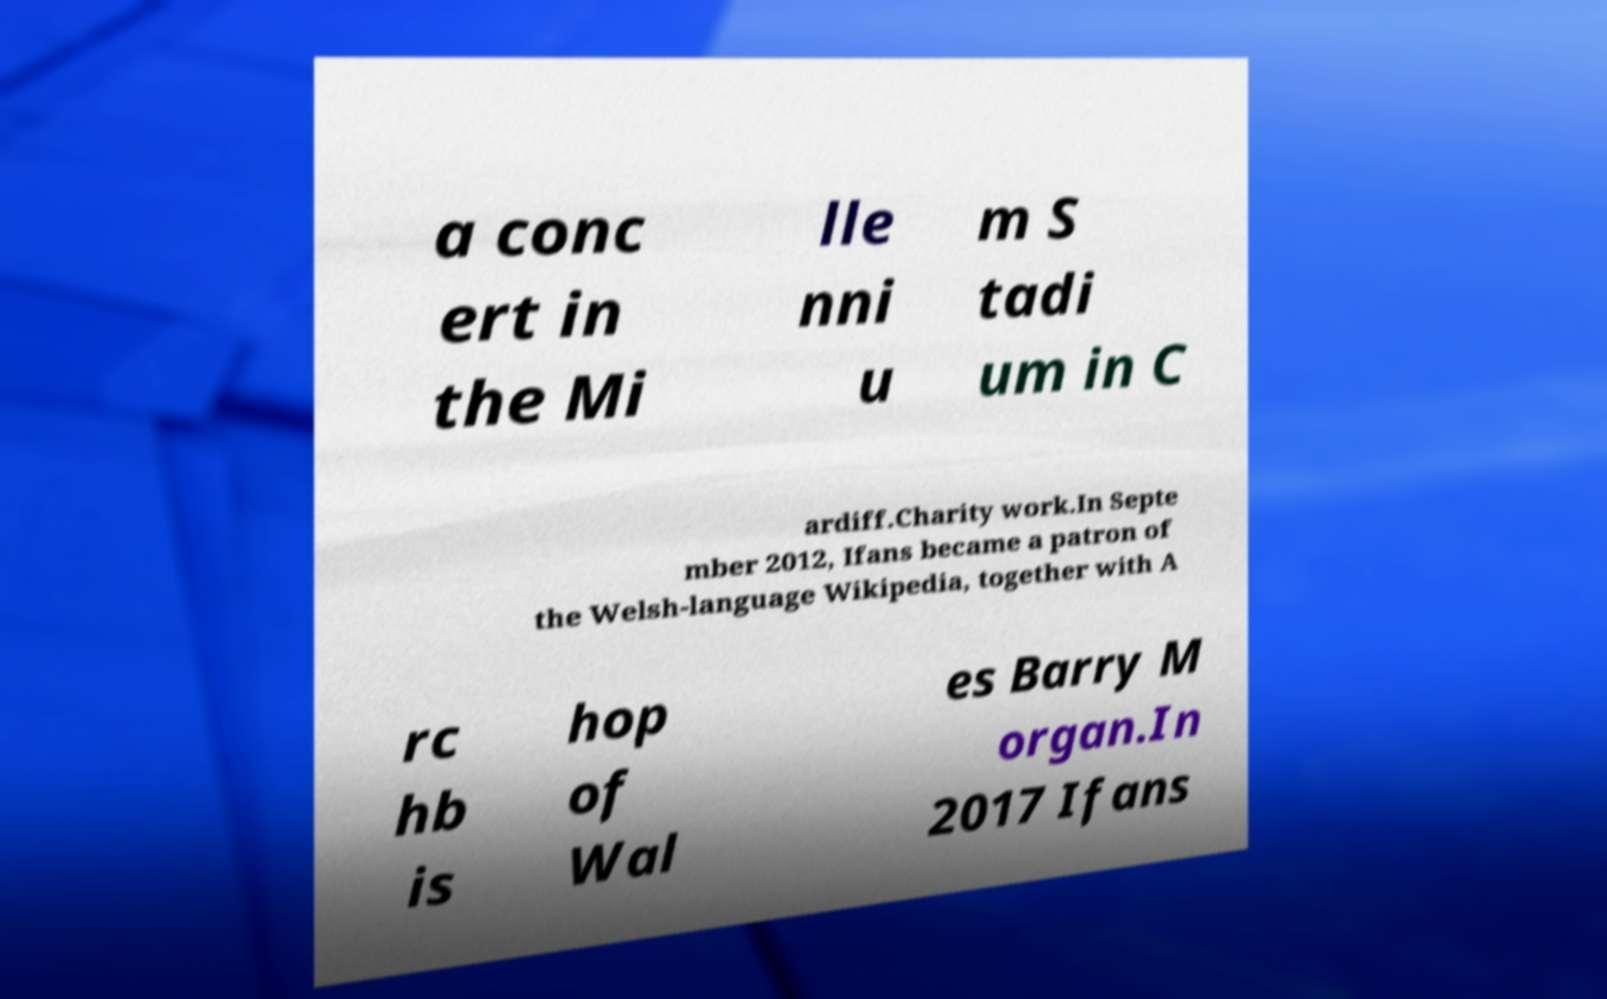What messages or text are displayed in this image? I need them in a readable, typed format. a conc ert in the Mi lle nni u m S tadi um in C ardiff.Charity work.In Septe mber 2012, Ifans became a patron of the Welsh-language Wikipedia, together with A rc hb is hop of Wal es Barry M organ.In 2017 Ifans 